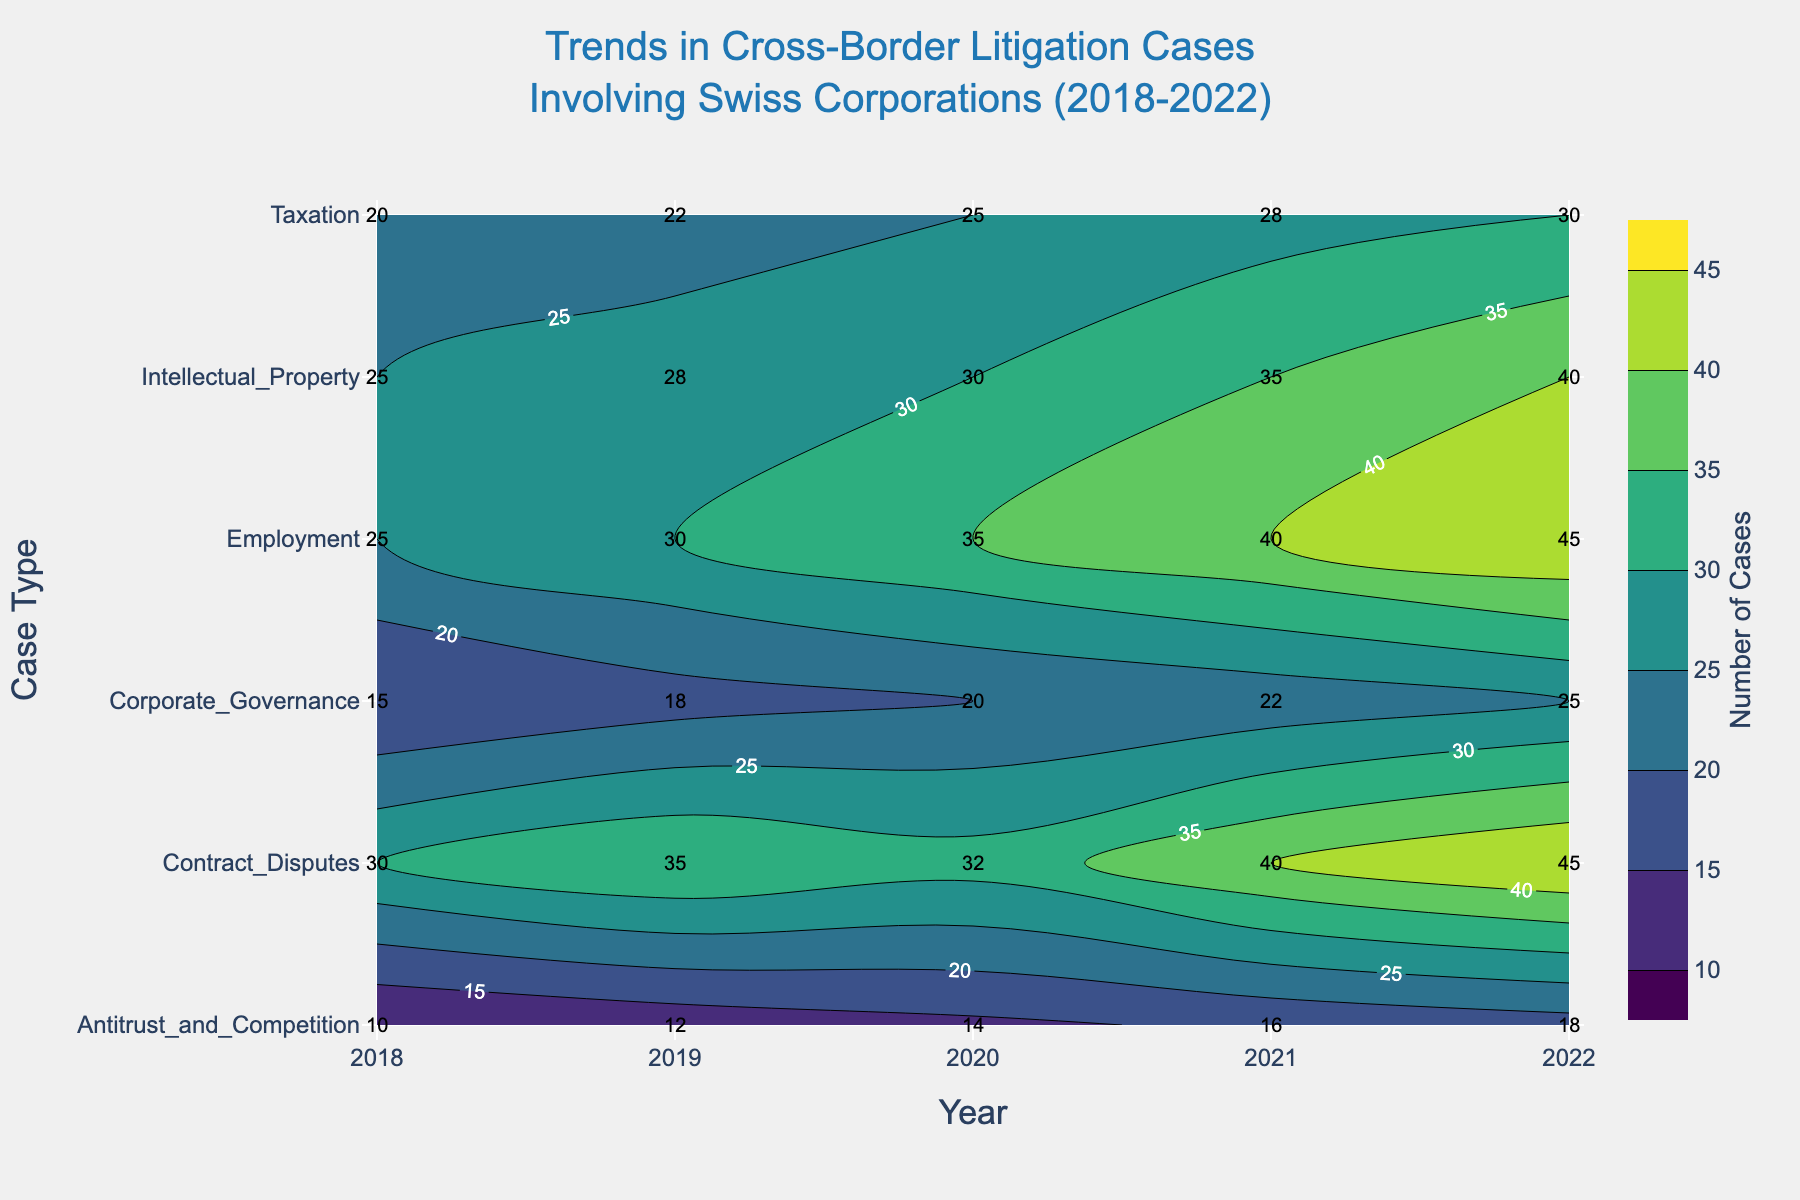What is the title of the figure? The title appears at the top of the figure in a larger font. It reads "Trends in Cross-Border Litigation Cases Involving Swiss Corporations (2018-2022)".
Answer: Trends in Cross-Border Litigation Cases Involving Swiss Corporations (2018-2022) How many different case types are represented in the plot? The y-axis lists the different case types. The case types listed are Contract Disputes, Intellectual Property, Antitrust and Competition, Corporate Governance, Taxation, and Employment. Counting these shows there are 6 different case types.
Answer: 6 Which case type had the highest number of cases in 2022? The year 2022 is the last entry on the x-axis, and we look at the corresponding y-axis labels to see which one has the highest contour value. The highest number of cases in 2022 is at Employment with 45 cases.
Answer: Employment What trend do we observe for Contract Disputes from 2018 to 2022? Follow the contour line for Contract Disputes along the x-axis from 2018 to 2022. The number of cases starts at 30 in 2018 and steadily increases each year, reaching 45 in 2022.
Answer: Increasing By how many cases did Intellectual Property disputes increase from 2018 to 2022? Subtract the number of cases in 2018 from the number of cases in 2022 for Intellectual Property. The number of cases in 2018 is 25 and in 2022 is 40. The increase is 40 - 25 = 15 cases.
Answer: 15 Which year had the highest number of total cases involving Antitrust and Competition disputes? Check the contour values for each year specifically for Antitrust and Competition and identify the year with the highest value. The highest value is 18 in 2022.
Answer: 2022 Are there any case types that saw a decrease in the number of cases from 2021 to 2022? Compare the contour values for each case type between 2021 and 2022. All types either increase or remain the same; none of them decrease.
Answer: No How does the number of Employment cases in 2020 compare to the number of Corporate Governance cases in 2020? Look at the respective contour values for Employment and Corporate Governance in 2020. The number of Employment cases is 35 and for Corporate Governance is 20.
Answer: Employment > Corporate Governance What is the total number of cases in 2019? Sum the contour values for 2019 across all case types: 35 (Contract Disputes) + 28 (Intellectual Property) + 12 (Antitrust and Competition) + 18 (Corporate Governance) + 22 (Taxation) + 30 (Employment) = 145 cases.
Answer: 145 Which year shows the most significant increase in Contract Disputes cases compared to the previous year? Calculate the yearly difference in Contract Disputes cases: 2019 (35 - 30 = 5), 2020 (32 - 35 = -3), 2021 (40 - 32 = 8), and 2022 (45 - 40 = 5). The most significant increase is 8 cases from 2020 to 2021.
Answer: 2020 to 2021 